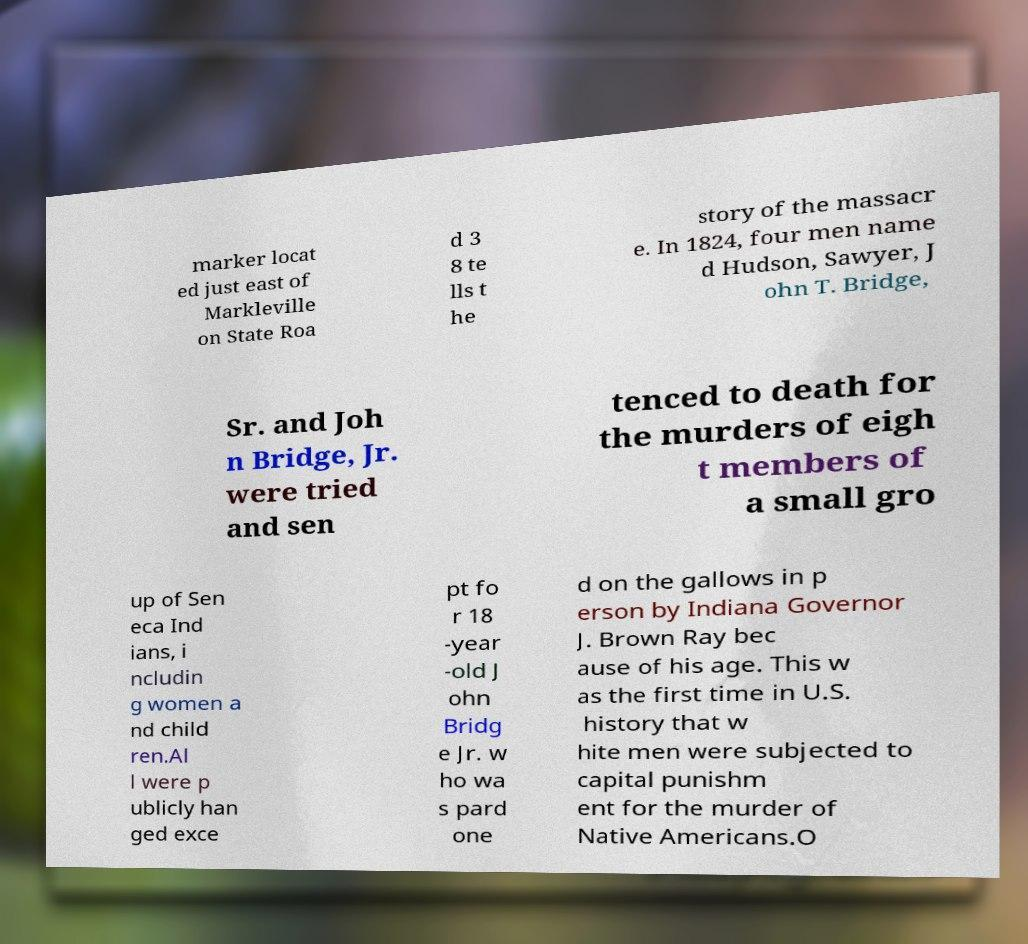For documentation purposes, I need the text within this image transcribed. Could you provide that? marker locat ed just east of Markleville on State Roa d 3 8 te lls t he story of the massacr e. In 1824, four men name d Hudson, Sawyer, J ohn T. Bridge, Sr. and Joh n Bridge, Jr. were tried and sen tenced to death for the murders of eigh t members of a small gro up of Sen eca Ind ians, i ncludin g women a nd child ren.Al l were p ublicly han ged exce pt fo r 18 -year -old J ohn Bridg e Jr. w ho wa s pard one d on the gallows in p erson by Indiana Governor J. Brown Ray bec ause of his age. This w as the first time in U.S. history that w hite men were subjected to capital punishm ent for the murder of Native Americans.O 